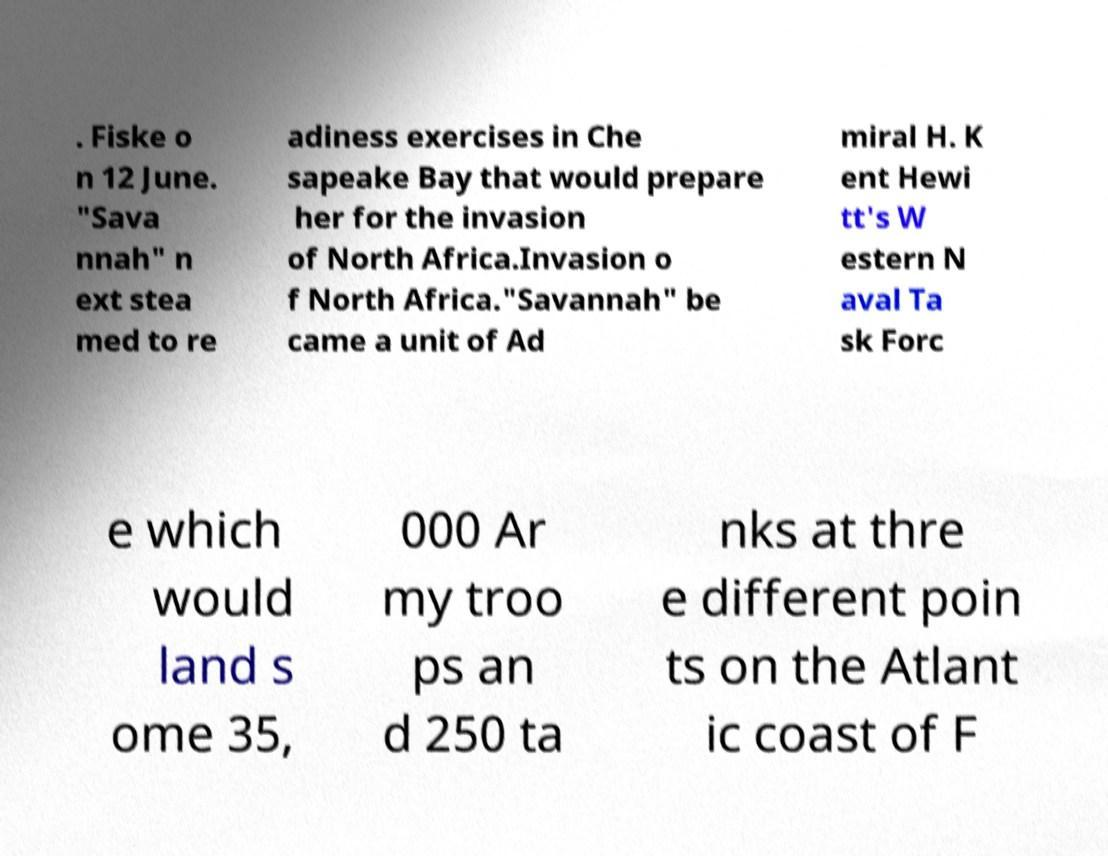Please read and relay the text visible in this image. What does it say? . Fiske o n 12 June. "Sava nnah" n ext stea med to re adiness exercises in Che sapeake Bay that would prepare her for the invasion of North Africa.Invasion o f North Africa."Savannah" be came a unit of Ad miral H. K ent Hewi tt's W estern N aval Ta sk Forc e which would land s ome 35, 000 Ar my troo ps an d 250 ta nks at thre e different poin ts on the Atlant ic coast of F 